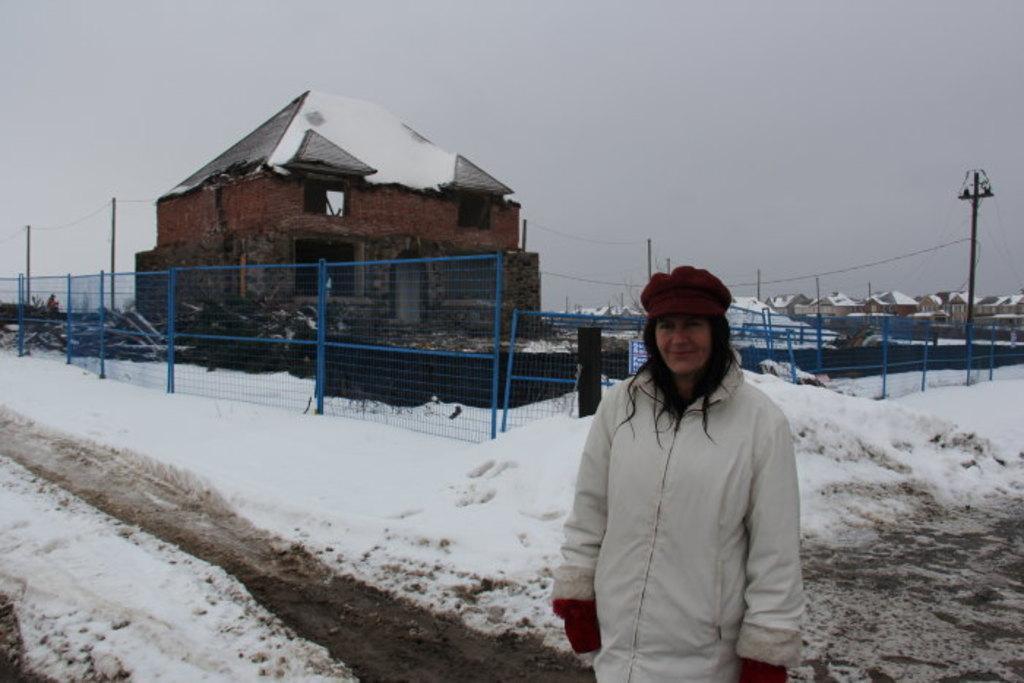In one or two sentences, can you explain what this image depicts? In the image there is a woman standing in the foreground and around the woman there is a lot of snow and behind the snow surface there is a house, around the house there is a fencing and in the background there are many other houses. 